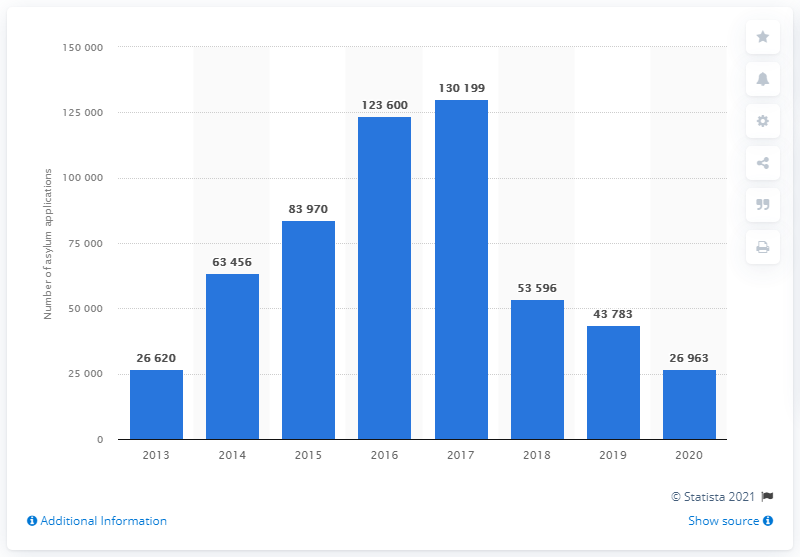Point out several critical features in this image. In 2020, a total of 26,963 asylum applications were submitted in Italy. 